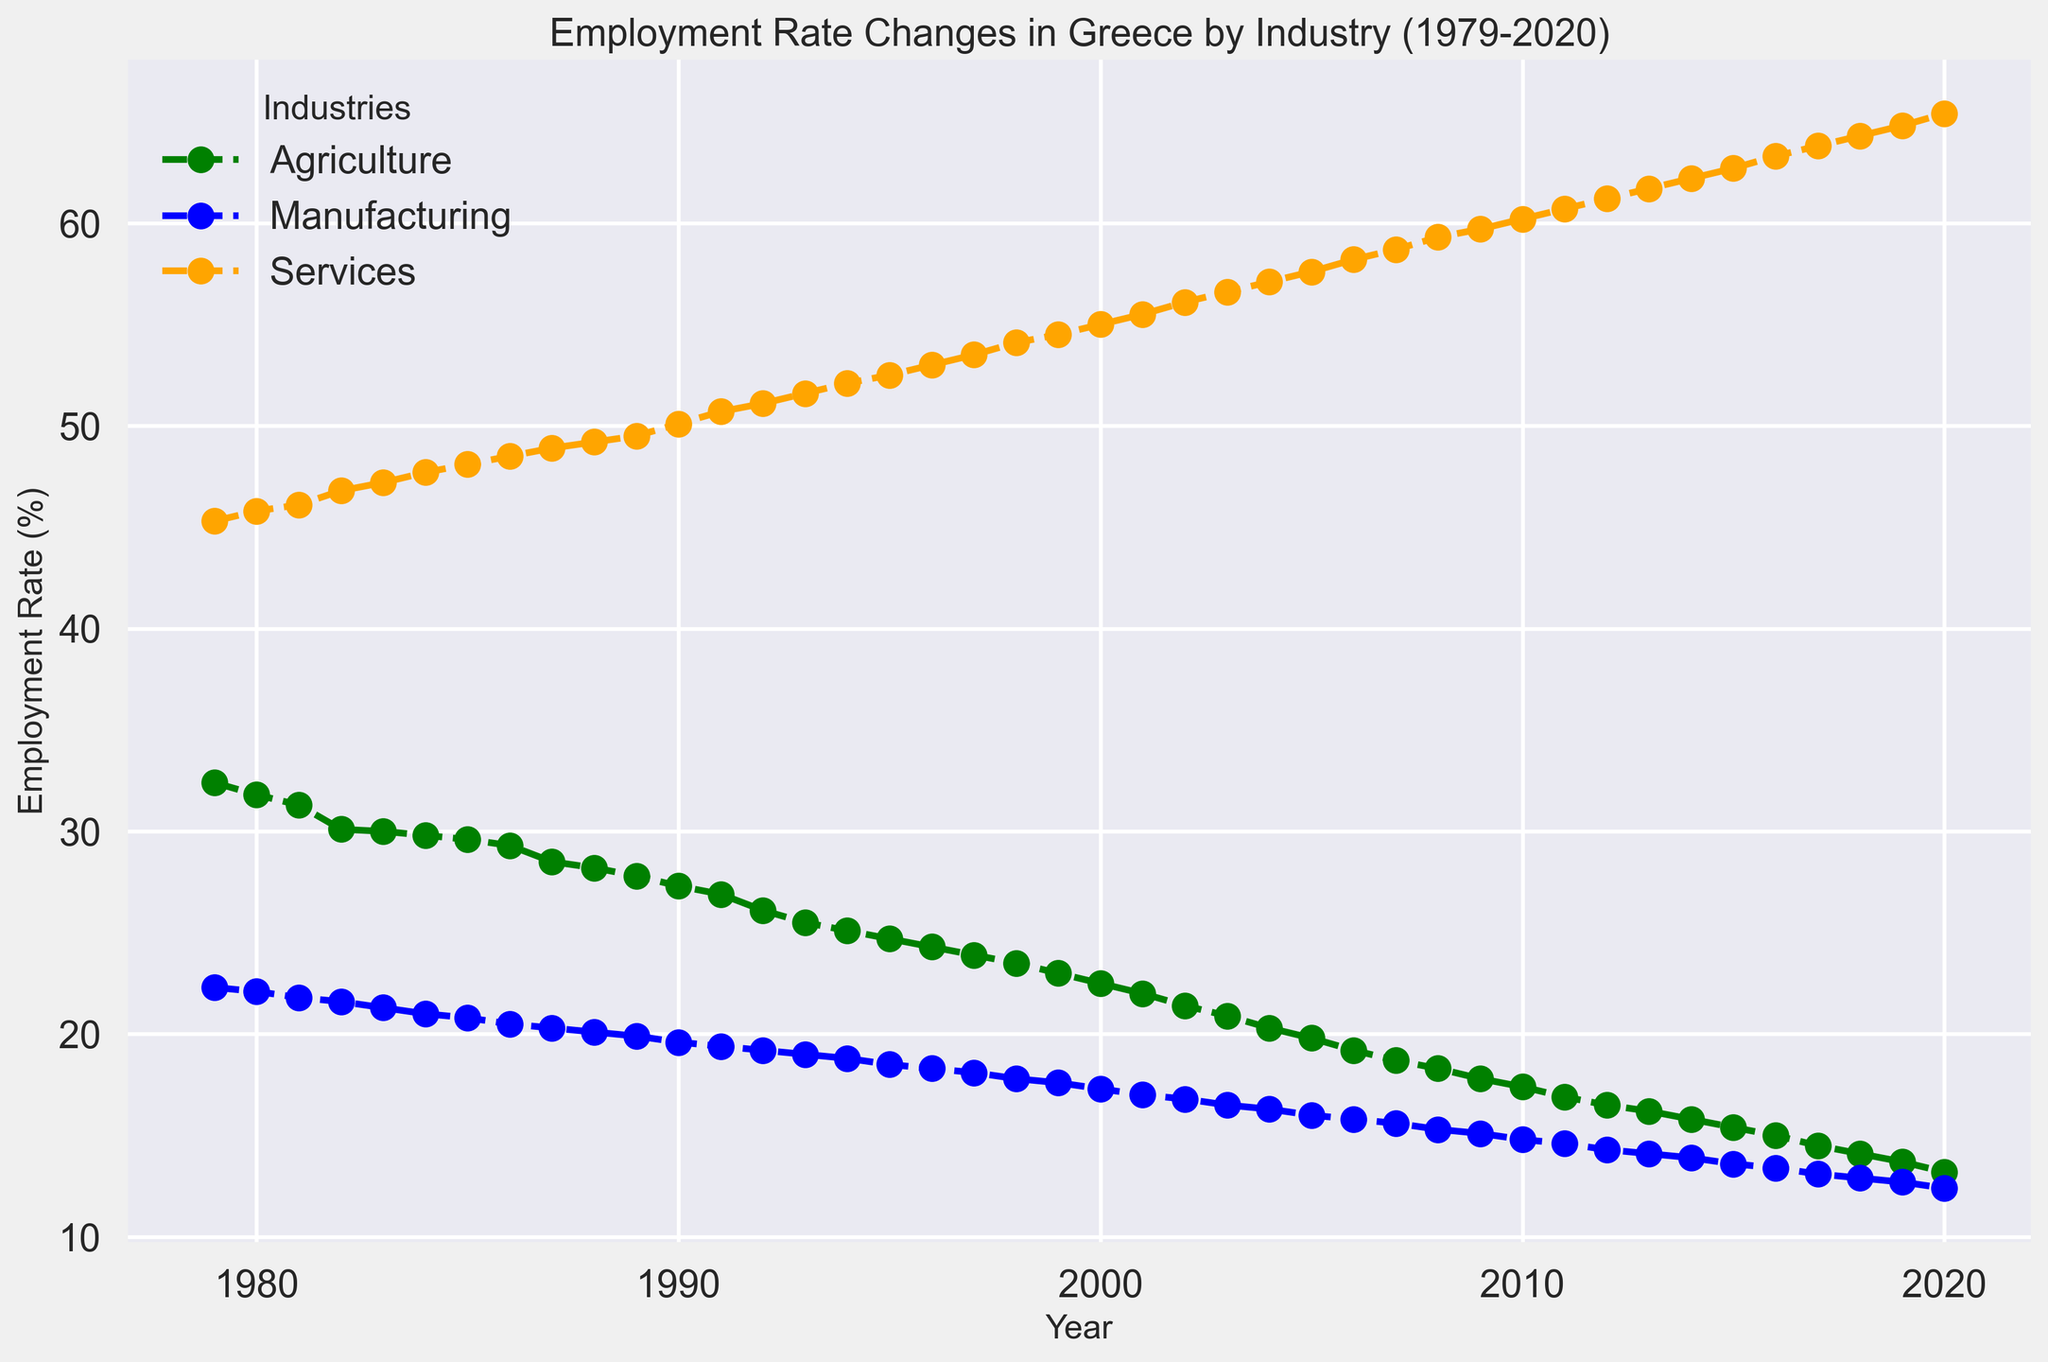Which industry saw the highest employment rate in 1979? The plot lines show employment rates by industry over the years, with the values for 1979 visible at the starting point of each line. The services industry line starts the highest.
Answer: Services How did the employment rate in agriculture change from 1980 to 1990? Find the values for agriculture in 1980 and 1990 from the plot, then calculate the difference. 1980: around 31.8%, 1990: around 27.3%. Subtract 27.3 from 31.8 to get the change.
Answer: Decrease by 4.5% Which industry showed a continuous increase in employment rate throughout the period? By examining the trends of the lines on the plot, the services industry line shows a steady increase without decline.
Answer: Services Compare the employment rate in manufacturing and services in 2005. Which was higher and by how much? Locate the 2005 mark on the plot and read the employment rates for both industries. Services: around 57.6%, Manufacturing: around 16.0%. Subtract 16.0 from 57.6.
Answer: Services was higher by 41.6% What is the general trend observed for employment in agriculture after Greece joined the EU? Identify the year Greece joined the EU (1981) and observe the agriculture trend after this year till the end of the plot. The line shows a consistent decline.
Answer: Declining What was the employment rate in the services industry in 1995, and how does it compare to that in 2000? Find the points for services in 1995 and 2000. 1995 is around 52.5%, and 2000 is around 55.0%. Subtract 52.5 from 55.0 to get the difference.
Answer: Increased by 2.5% Which industry shows the most significant decline in employment rate from 1979 to 2020? By comparing the overall decline in each industry's line, agriculture shows the largest decline from around 32.4% to 13.2%.
Answer: Agriculture By how much did the service sector's employment rate change from 1981 to 2011? Locate the years 1981 and 2011 for the services line. 1981: around 46.1%, 2011: around 60.7%. Subtract 46.1 from 60.7 to get the change.
Answer: Increased by 14.6% What was the employment rate in manufacturing in 1990 and how did it change by 2020? Find the rate for manufacturing in 1990 and 2020. 1990: around 19.6%, 2020: around 12.4%. Subtract 12.4 from 19.6.
Answer: Decreased by 7.2% Which year did the agriculture industry cross below the 20% employment rate? Track the agriculture line and find the year it first crosses below the 20% mark. This happens around 2005.
Answer: 2005 